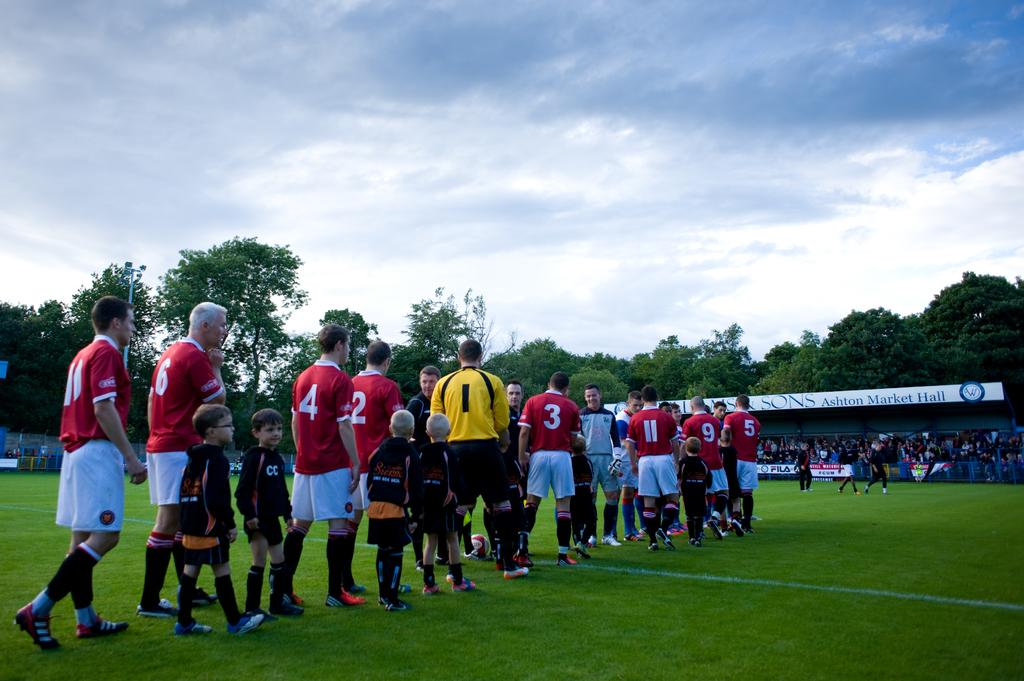What is the surface that the group of people is standing on in the image? The ground is covered in grass. What can be seen in the background of the image? There are trees, boards, and another group of people in the background of the image. What is visible in the sky in the image? The sky is visible in the background of the image. What type of substance is being spread on the pancake in the image? There is no pancake or substance present in the image. What is the butter being used for in the image? There is no butter present in the image. 